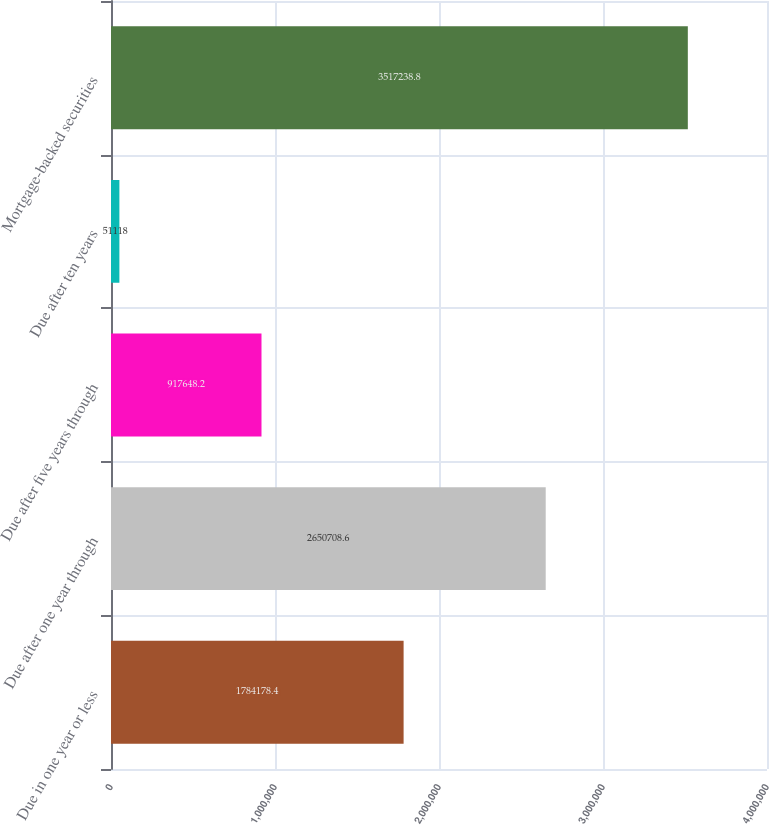Convert chart to OTSL. <chart><loc_0><loc_0><loc_500><loc_500><bar_chart><fcel>Due in one year or less<fcel>Due after one year through<fcel>Due after five years through<fcel>Due after ten years<fcel>Mortgage-backed securities<nl><fcel>1.78418e+06<fcel>2.65071e+06<fcel>917648<fcel>51118<fcel>3.51724e+06<nl></chart> 